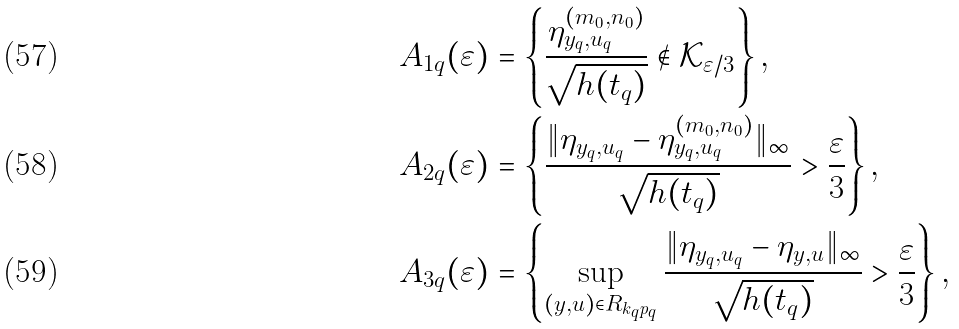<formula> <loc_0><loc_0><loc_500><loc_500>A _ { 1 q } ( \varepsilon ) & = \left \{ \frac { \eta ^ { ( m _ { 0 } , n _ { 0 } ) } _ { y _ { q } , u _ { q } } } { \sqrt { h ( t _ { q } ) } } \notin \mathcal { K } _ { \varepsilon / 3 } \right \} , \\ A _ { 2 q } ( \varepsilon ) & = \left \{ \frac { \| \eta _ { y _ { q } , u _ { q } } - \eta ^ { ( m _ { 0 } , n _ { 0 } ) } _ { y _ { q } , u _ { q } } \| _ { \infty } } { \sqrt { h ( t _ { q } ) } } > \frac { \varepsilon } { 3 } \right \} , \\ A _ { 3 q } ( \varepsilon ) & = \left \{ \sup _ { ( y , u ) \in R _ { k _ { q } p _ { q } } } \frac { \| \eta _ { y _ { q } , u _ { q } } - \eta _ { y , u } \| _ { \infty } } { \sqrt { h ( t _ { q } ) } } > \frac { \varepsilon } { 3 } \right \} ,</formula> 